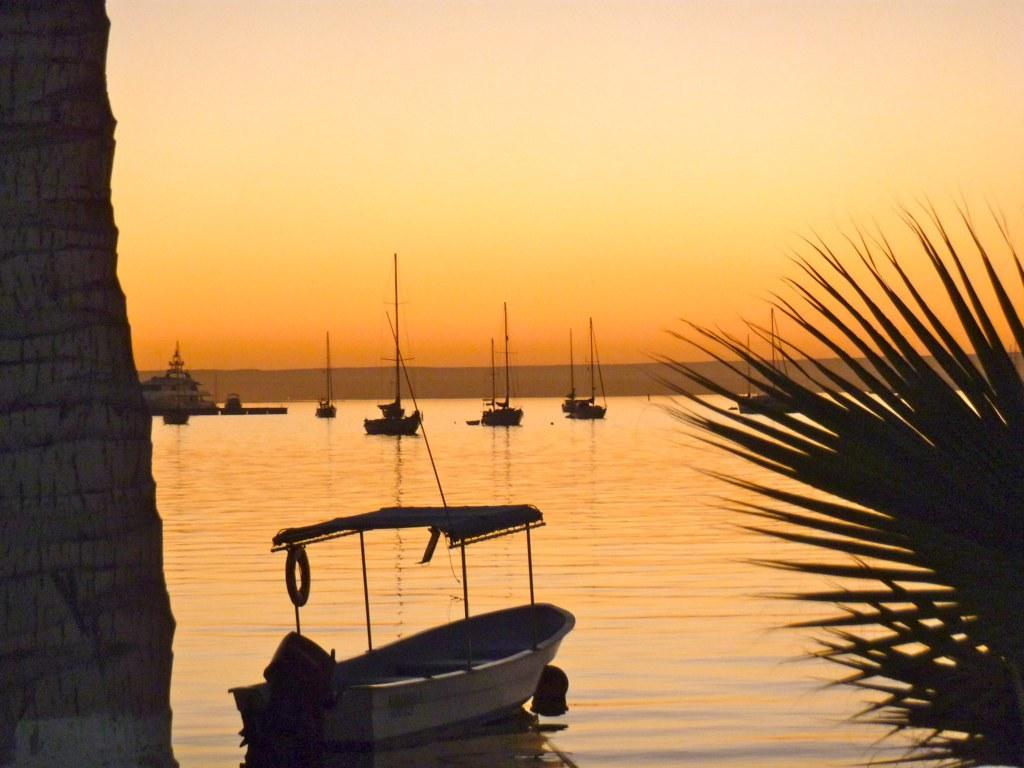What is in the water in the image? There are boats in the water in the image. What type of vegetation can be seen in the image? Trees are visible in the image. What is visible in the background of the image? The sky is visible in the background of the image. Can you see any pipes in the image? There are no pipes visible in the image. Are there any bats flying in the trees in the image? There is no mention of bats in the image, only trees and boats in the water. 